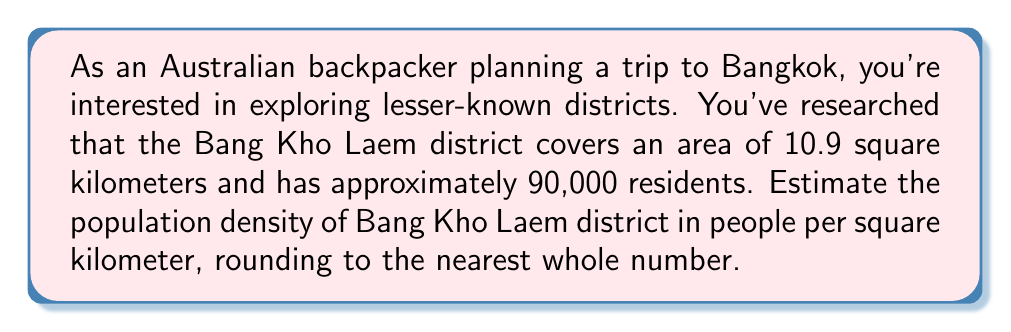Can you solve this math problem? To calculate the population density, we need to divide the total population by the area of the district. The formula for population density is:

$$\text{Population Density} = \frac{\text{Total Population}}{\text{Total Area}}$$

Given:
- Total Population of Bang Kho Laem: 90,000
- Total Area of Bang Kho Laem: 10.9 square kilometers

Let's substitute these values into the formula:

$$\text{Population Density} = \frac{90,000}{10.9} \approx 8,256.88 \text{ people/km}^2$$

Rounding to the nearest whole number:

$$8,256.88 \approx 8,257 \text{ people/km}^2$$

This result gives us an estimate of the population density in Bang Kho Laem district, which can help you understand how crowded or sparse this lesser-known area of Bangkok might be compared to more touristy districts.
Answer: $8,257 \text{ people/km}^2$ 